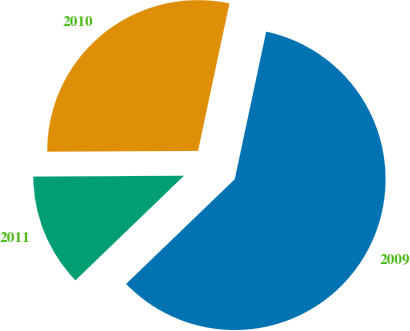Convert chart. <chart><loc_0><loc_0><loc_500><loc_500><pie_chart><fcel>2009<fcel>2010<fcel>2011<nl><fcel>59.46%<fcel>28.43%<fcel>12.12%<nl></chart> 